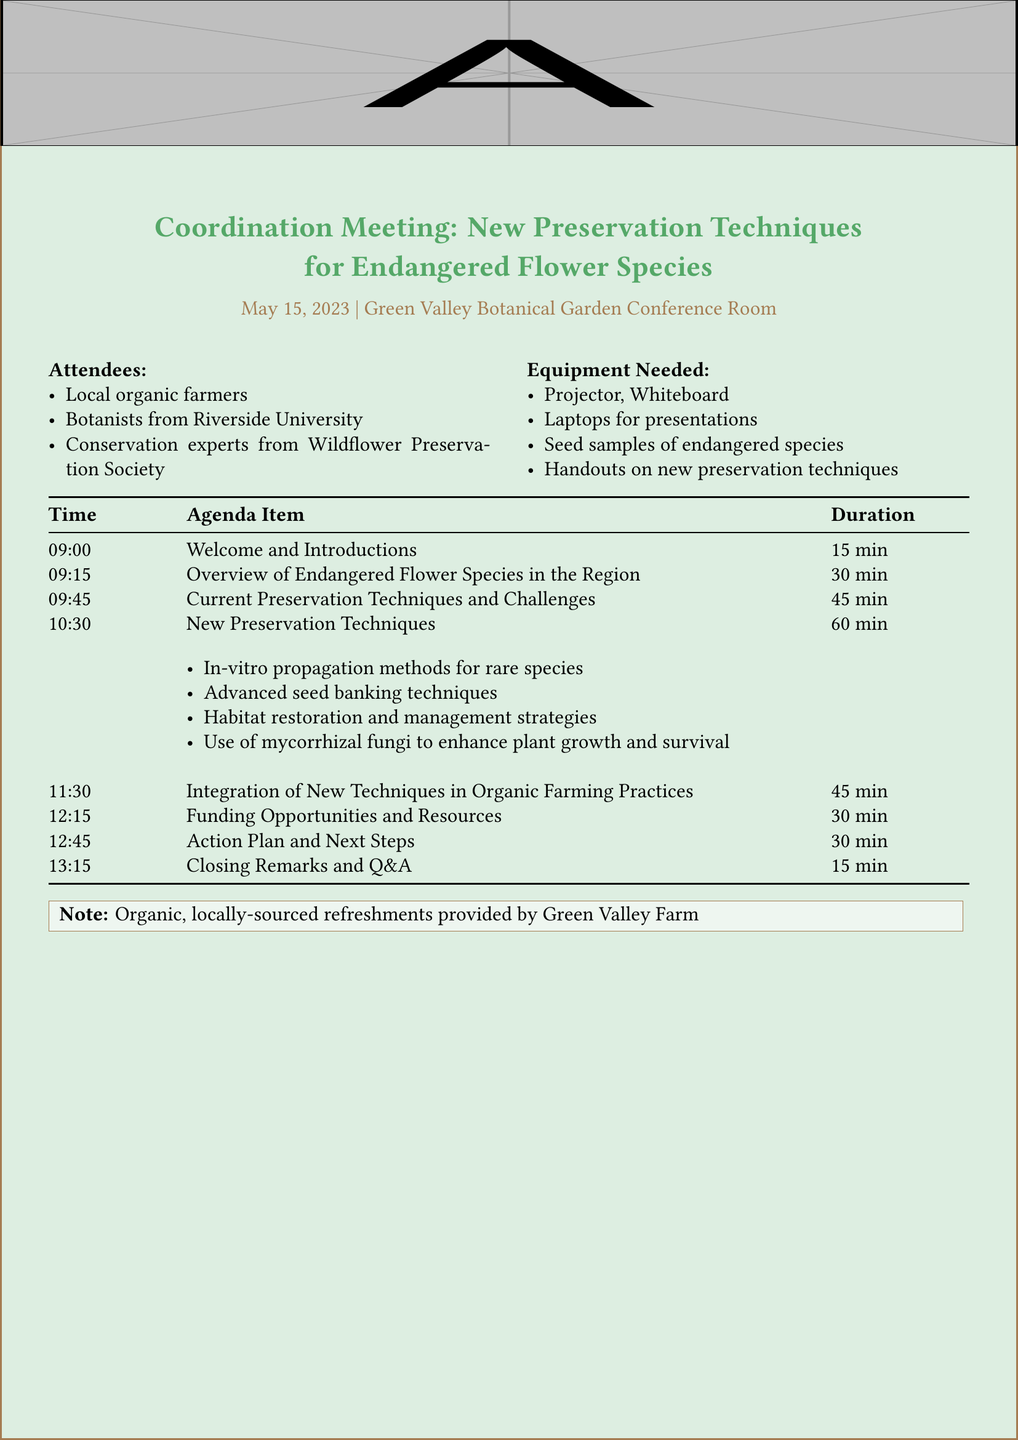What is the date of the meeting? The date of the meeting is included in the document.
Answer: May 15, 2023 Who is leading the presentation on endangered flower species? The document specifies who will give the presentation on endangered flower species.
Answer: Dr. Emily Chen How long is the discussion on current preservation techniques? The duration of the discussion is stated in the agenda section.
Answer: 45 minutes What are the subtopics under new preservation techniques? The document lists the subtopics within the agenda item for new preservation techniques.
Answer: In-vitro propagation methods for rare species, Advanced seed banking techniques, Habitat restoration and management strategies, Use of mycorrhizal fungi to enhance plant growth and survival What is the purpose of the action plan session? The document provides details on the objectives of the action plan session.
Answer: To develop a concrete action plan for implementing new preservation techniques and assigning responsibilities Who provides refreshments? The source of refreshments is noted in the document.
Answer: Green Valley Farm 